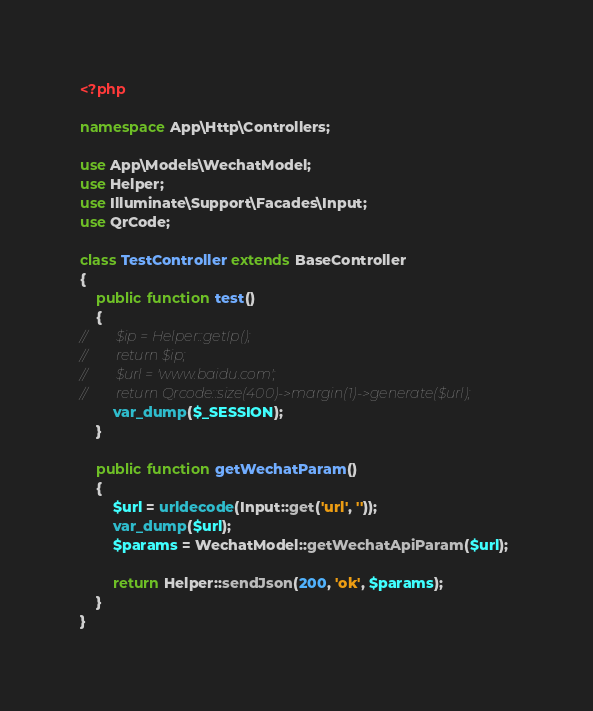Convert code to text. <code><loc_0><loc_0><loc_500><loc_500><_PHP_><?php

namespace App\Http\Controllers;

use App\Models\WechatModel;
use Helper;
use Illuminate\Support\Facades\Input;
use QrCode;

class TestController extends BaseController
{
    public function test()
    {
//        $ip = Helper::getIp();
//        return $ip;
//        $url = 'www.baidu.com';
//        return Qrcode::size(400)->margin(1)->generate($url);
        var_dump($_SESSION);
    }

    public function getWechatParam()
    {
        $url = urldecode(Input::get('url', ''));
        var_dump($url);
        $params = WechatModel::getWechatApiParam($url);

        return Helper::sendJson(200, 'ok', $params);
    }
}</code> 